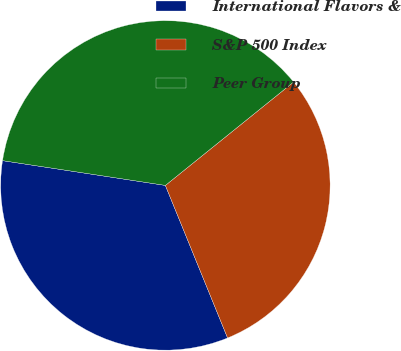Convert chart. <chart><loc_0><loc_0><loc_500><loc_500><pie_chart><fcel>International Flavors &<fcel>S&P 500 Index<fcel>Peer Group<nl><fcel>33.57%<fcel>29.64%<fcel>36.8%<nl></chart> 